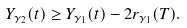Convert formula to latex. <formula><loc_0><loc_0><loc_500><loc_500>Y _ { \gamma _ { 2 } } ( t ) \geq Y _ { \gamma _ { 1 } } ( t ) - 2 r _ { \gamma _ { 1 } } ( T ) .</formula> 